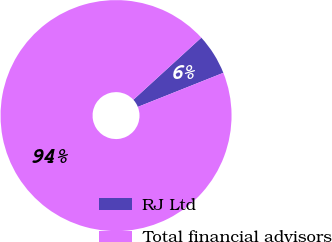Convert chart. <chart><loc_0><loc_0><loc_500><loc_500><pie_chart><fcel>RJ Ltd<fcel>Total financial advisors<nl><fcel>5.75%<fcel>94.25%<nl></chart> 